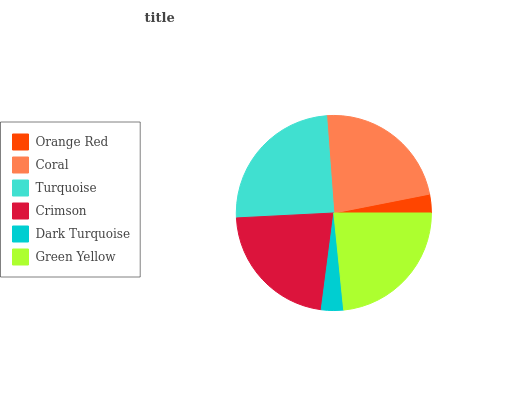Is Orange Red the minimum?
Answer yes or no. Yes. Is Turquoise the maximum?
Answer yes or no. Yes. Is Coral the minimum?
Answer yes or no. No. Is Coral the maximum?
Answer yes or no. No. Is Coral greater than Orange Red?
Answer yes or no. Yes. Is Orange Red less than Coral?
Answer yes or no. Yes. Is Orange Red greater than Coral?
Answer yes or no. No. Is Coral less than Orange Red?
Answer yes or no. No. Is Coral the high median?
Answer yes or no. Yes. Is Crimson the low median?
Answer yes or no. Yes. Is Dark Turquoise the high median?
Answer yes or no. No. Is Green Yellow the low median?
Answer yes or no. No. 